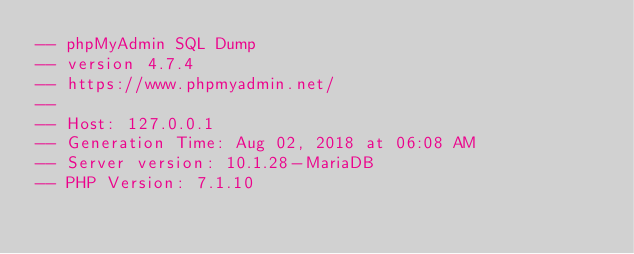<code> <loc_0><loc_0><loc_500><loc_500><_SQL_>-- phpMyAdmin SQL Dump
-- version 4.7.4
-- https://www.phpmyadmin.net/
--
-- Host: 127.0.0.1
-- Generation Time: Aug 02, 2018 at 06:08 AM
-- Server version: 10.1.28-MariaDB
-- PHP Version: 7.1.10
</code> 